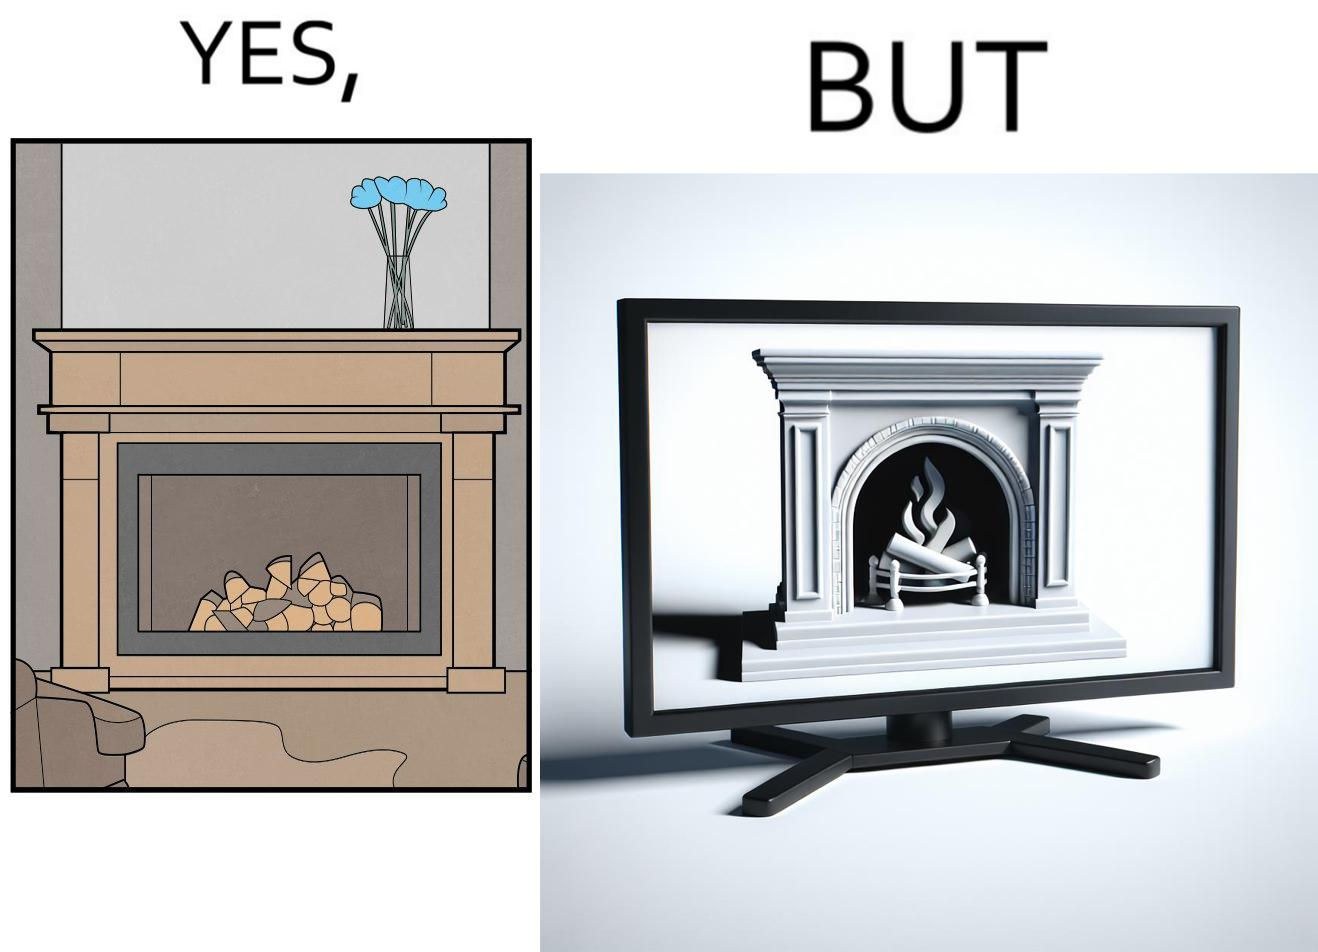Describe the satirical element in this image. The images are funny since they show how even though real fireplaces exist, people choose to be lazy and watch fireplaces on television because they dont want the inconveniences of cleaning up, etc. afterwards 